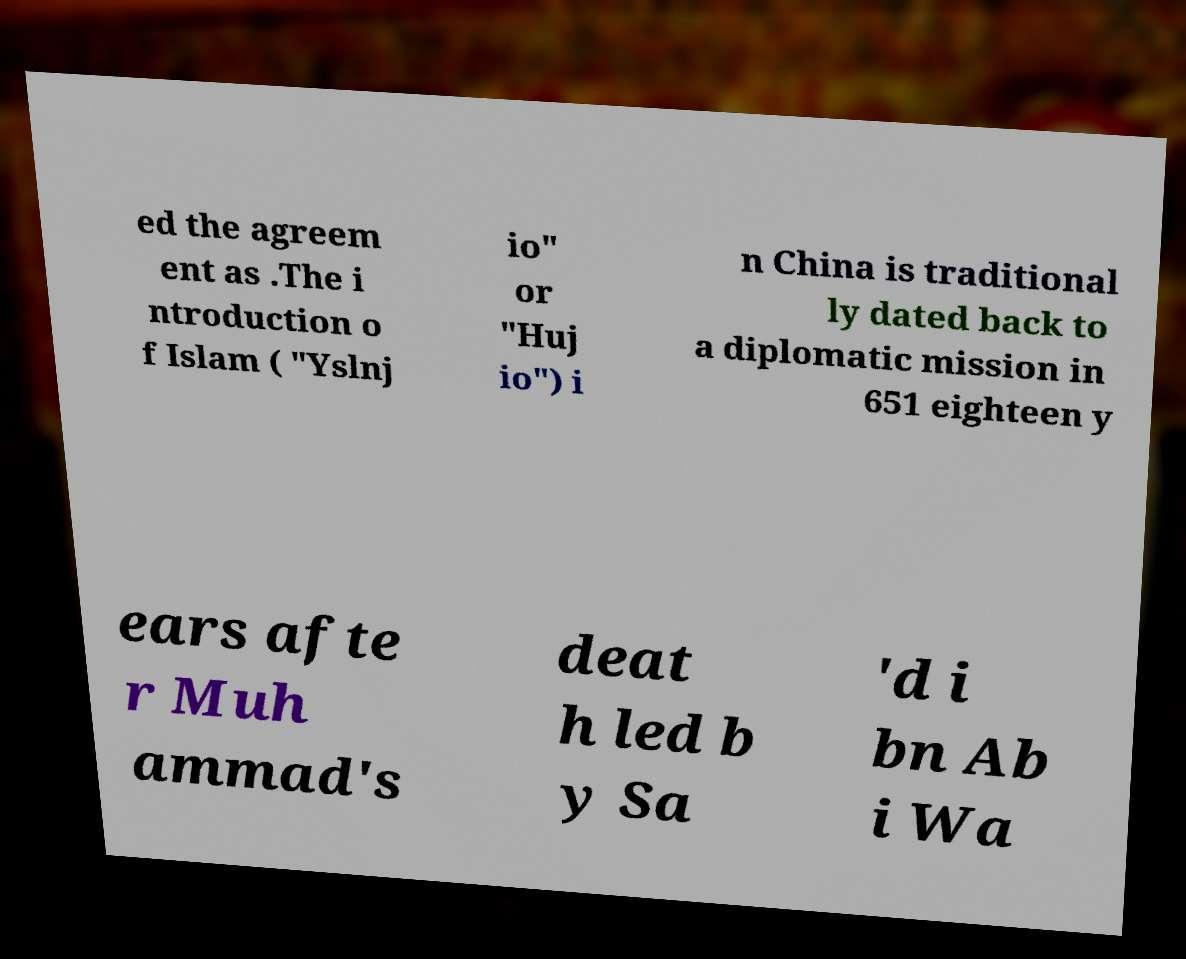Could you assist in decoding the text presented in this image and type it out clearly? ed the agreem ent as .The i ntroduction o f Islam ( "Yslnj io" or "Huj io") i n China is traditional ly dated back to a diplomatic mission in 651 eighteen y ears afte r Muh ammad's deat h led b y Sa 'd i bn Ab i Wa 